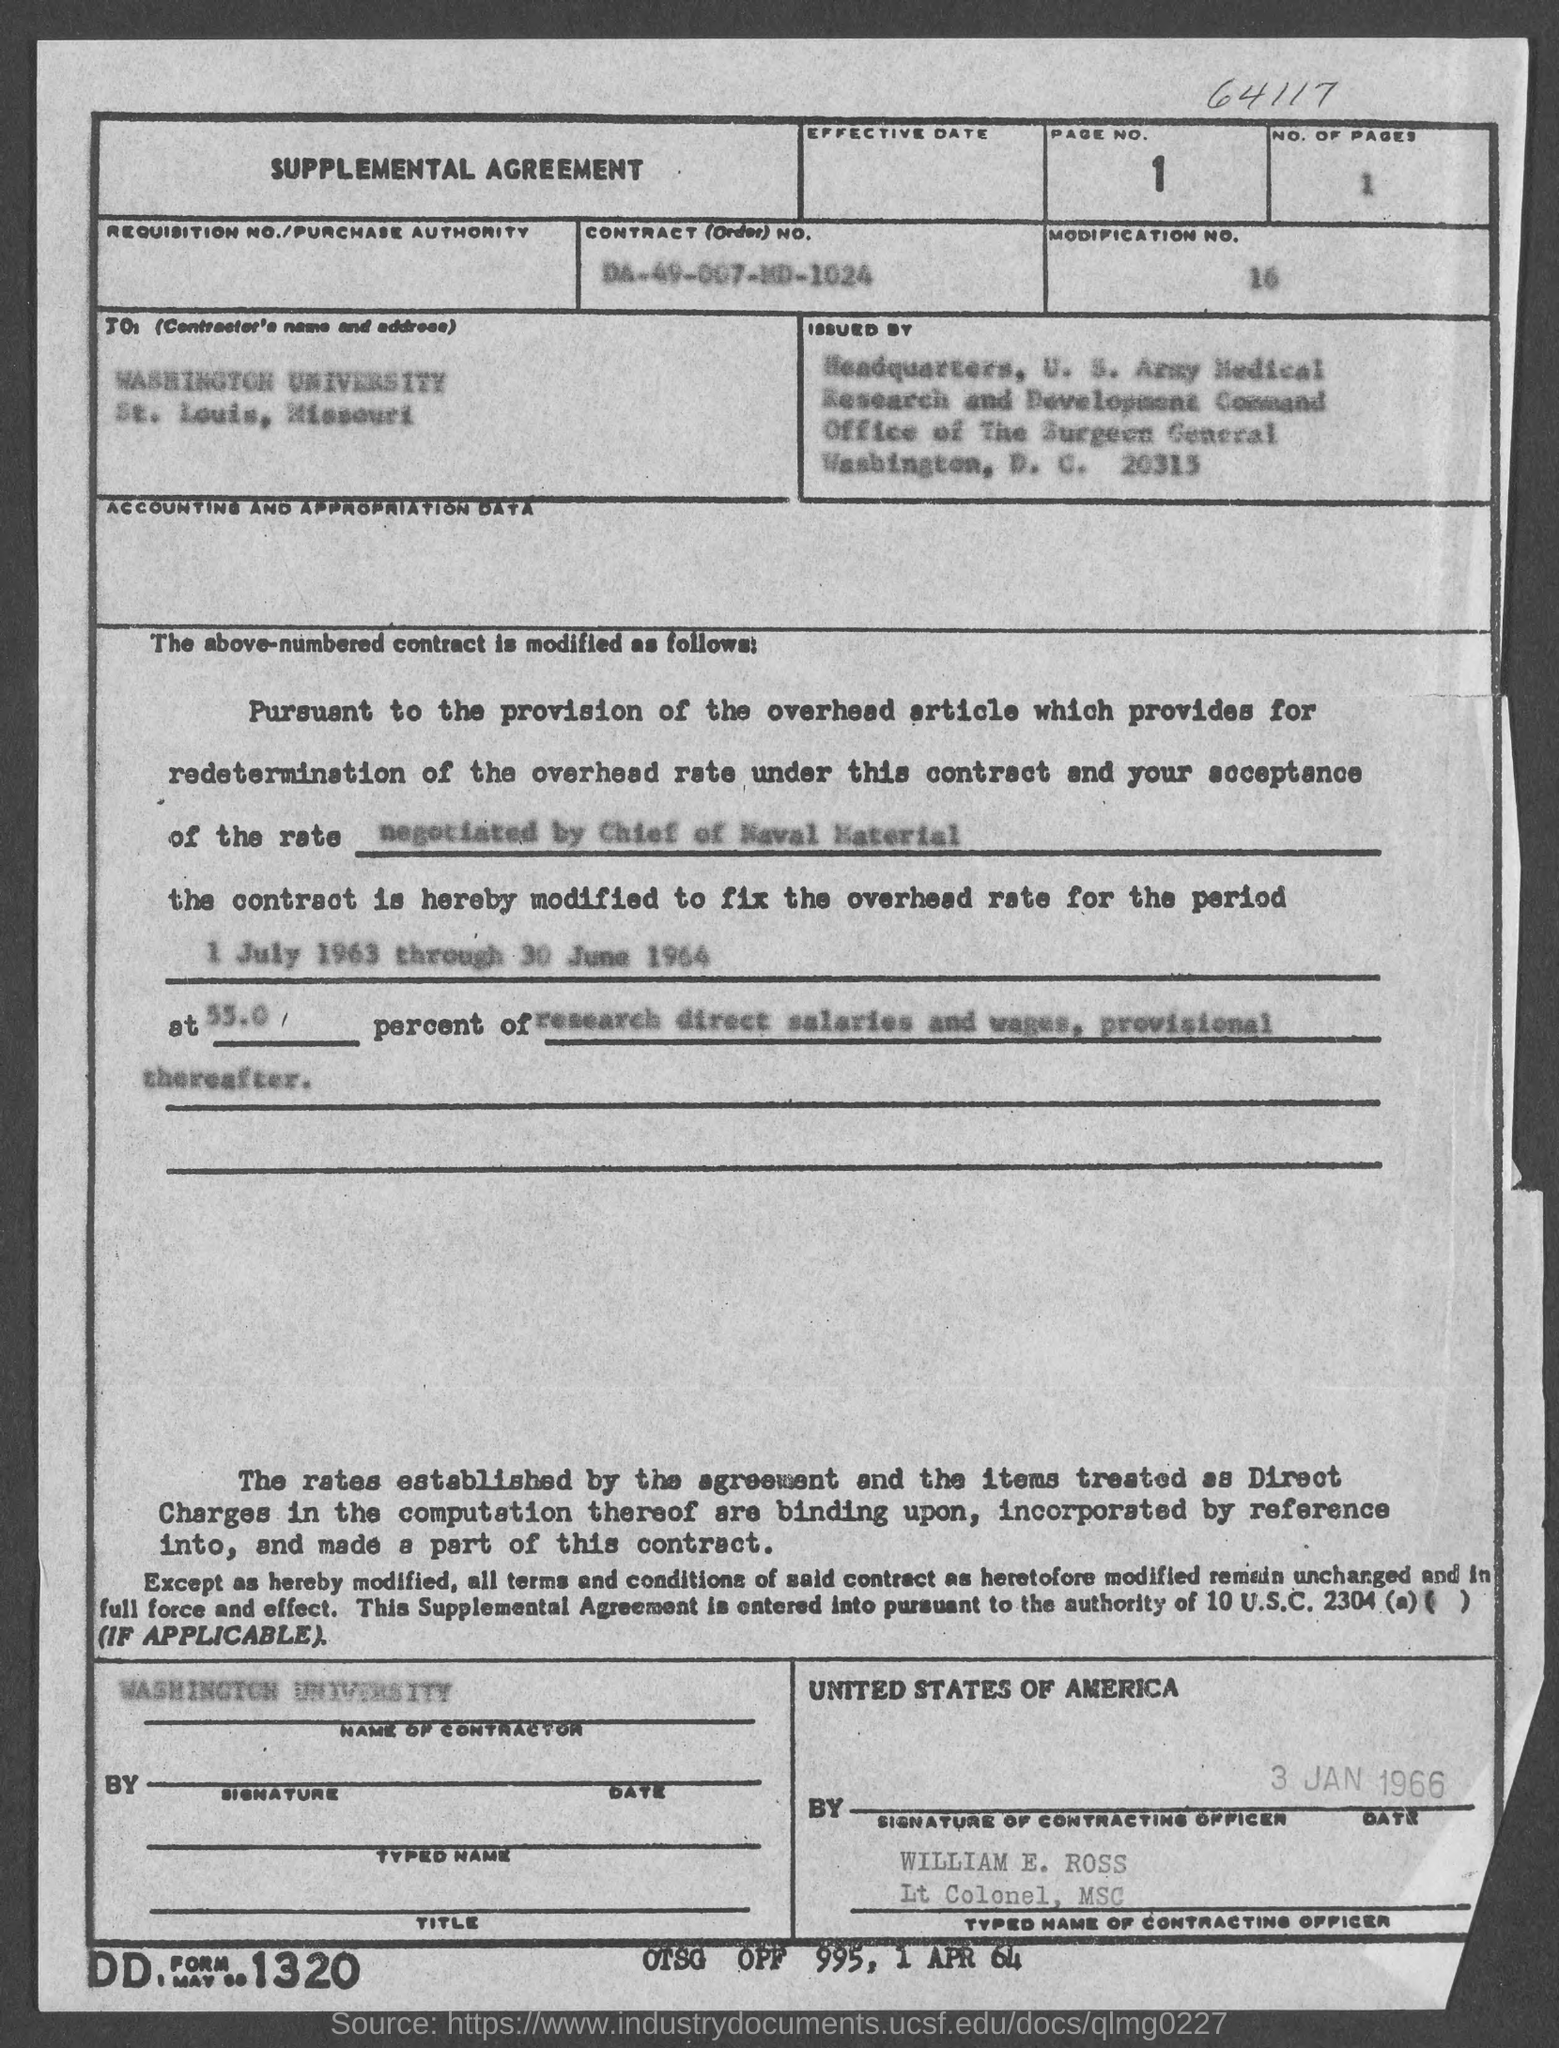Indicate a few pertinent items in this graphic. The number of pages is 1...". The page number is 1 and the numbers continue on from there. The contract number is DA-49-007-MD-1024. The location of Washington University in St. Louis, Missouri, is known as Washington University. The contracting officer's name is William E. Ross. 